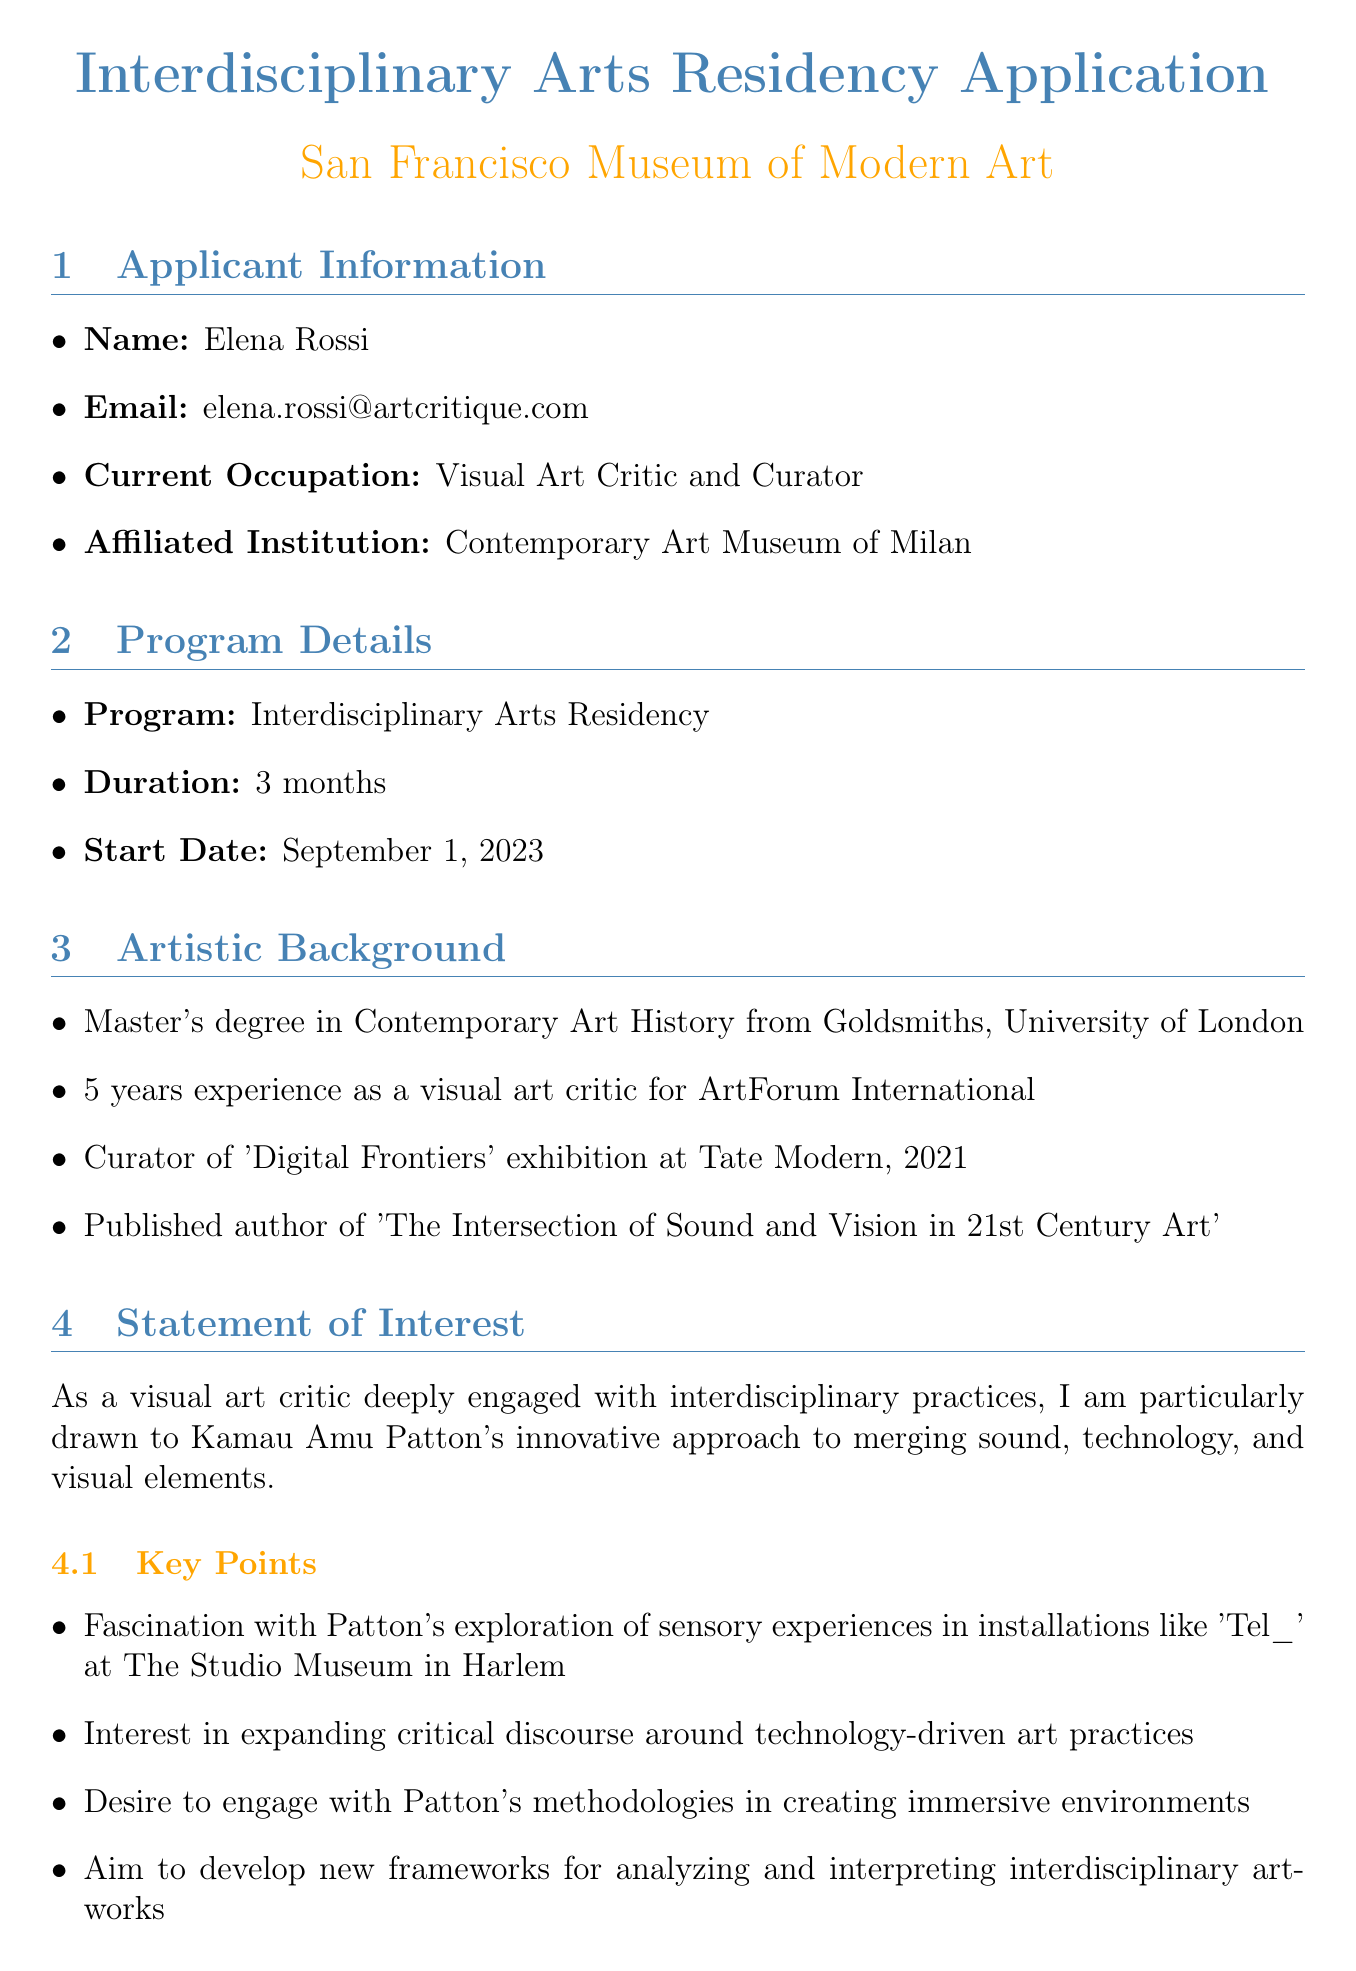What is the applicant's full name? The applicant's full name is presented in the "Applicant Information" section of the document.
Answer: Elena Rossi What is the host institution for the program? The host institution for the "Interdisciplinary Arts Residency" is specified in the "Program Details" section of the document.
Answer: San Francisco Museum of Modern Art What is the duration of the residency? The duration of the residency is clearly stated in the "Program Details" section.
Answer: 3 months What project does the applicant propose during the residency? The project proposal provided in the "Statement of Interest" outlines the applicant's intentions during the residency.
Answer: A series of critical essays and video documentaries Which exhibition did the applicant curate in 2021? The specific exhibition the applicant curated is mentioned in the "Artistic Background" section.
Answer: Digital Frontiers What is the applicant's interest in Kamau Amu Patton's work? The key points in the "Statement of Interest" elaborates on the applicant's interest in Patton's work.
Answer: Exploration of sensory experiences How many references are provided in the application? The "References" section indicates the number of references included in the application.
Answer: 2 What language fluencies does the applicant have? The "Relevant Skills" section specifies the languages the applicant is fluent in.
Answer: English, Italian, and French 